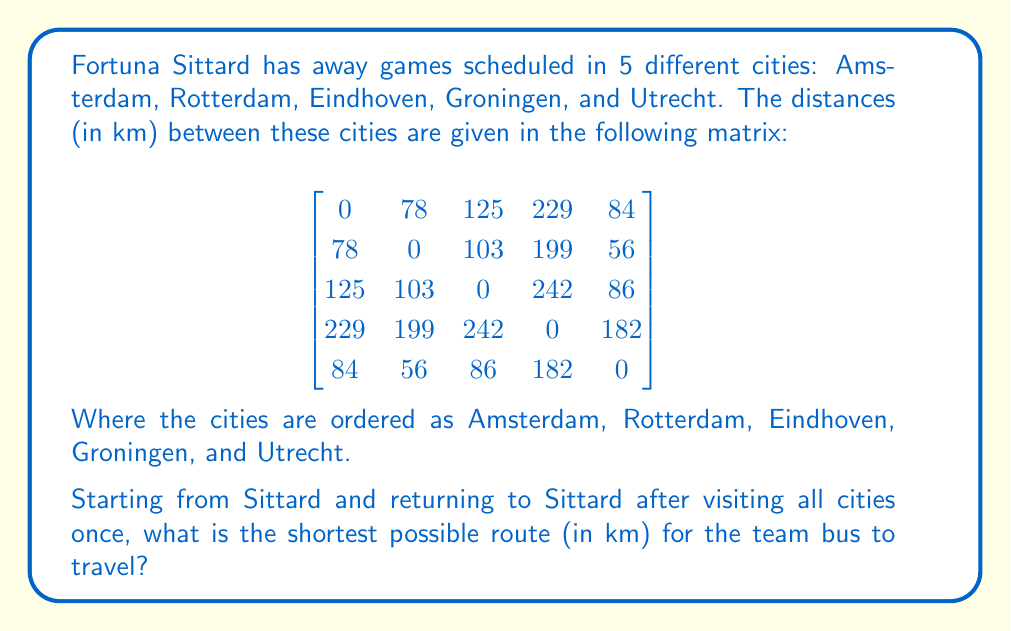Show me your answer to this math problem. This problem is an instance of the Traveling Salesman Problem (TSP), which is a classic optimization problem in operations research. To solve this, we'll use the nearest neighbor heuristic, which is a simple but effective approximation method.

Step 1: Start from Sittard (not in the matrix) and find the nearest city.
Sittard to Amsterdam: 214 km
Sittard to Rotterdam: 180 km
Sittard to Eindhoven: 61 km
Sittard to Groningen: 289 km
Sittard to Utrecht: 195 km

Eindhoven is the closest at 61 km.

Step 2: From Eindhoven, find the nearest unvisited city.
Eindhoven to Amsterdam: 125 km
Eindhoven to Rotterdam: 103 km
Eindhoven to Groningen: 242 km
Eindhoven to Utrecht: 86 km

Utrecht is the closest at 86 km.

Step 3: From Utrecht, find the nearest unvisited city.
Utrecht to Amsterdam: 84 km
Utrecht to Rotterdam: 56 km
Utrecht to Groningen: 182 km

Rotterdam is the closest at 56 km.

Step 4: From Rotterdam, find the nearest unvisited city.
Rotterdam to Amsterdam: 78 km
Rotterdam to Groningen: 199 km

Amsterdam is the closest at 78 km.

Step 5: The only city left is Groningen, so we go there next.
Amsterdam to Groningen: 229 km

Step 6: Return to Sittard from Groningen.
Groningen to Sittard: 289 km

The total distance is:
$$ 61 + 86 + 56 + 78 + 229 + 289 = 799 \text{ km} $$

Note: This is an approximation and may not be the absolute shortest route, but it provides a good estimate for the TSP.
Answer: The shortest approximate route for Fortuna Sittard's away games is 799 km. 